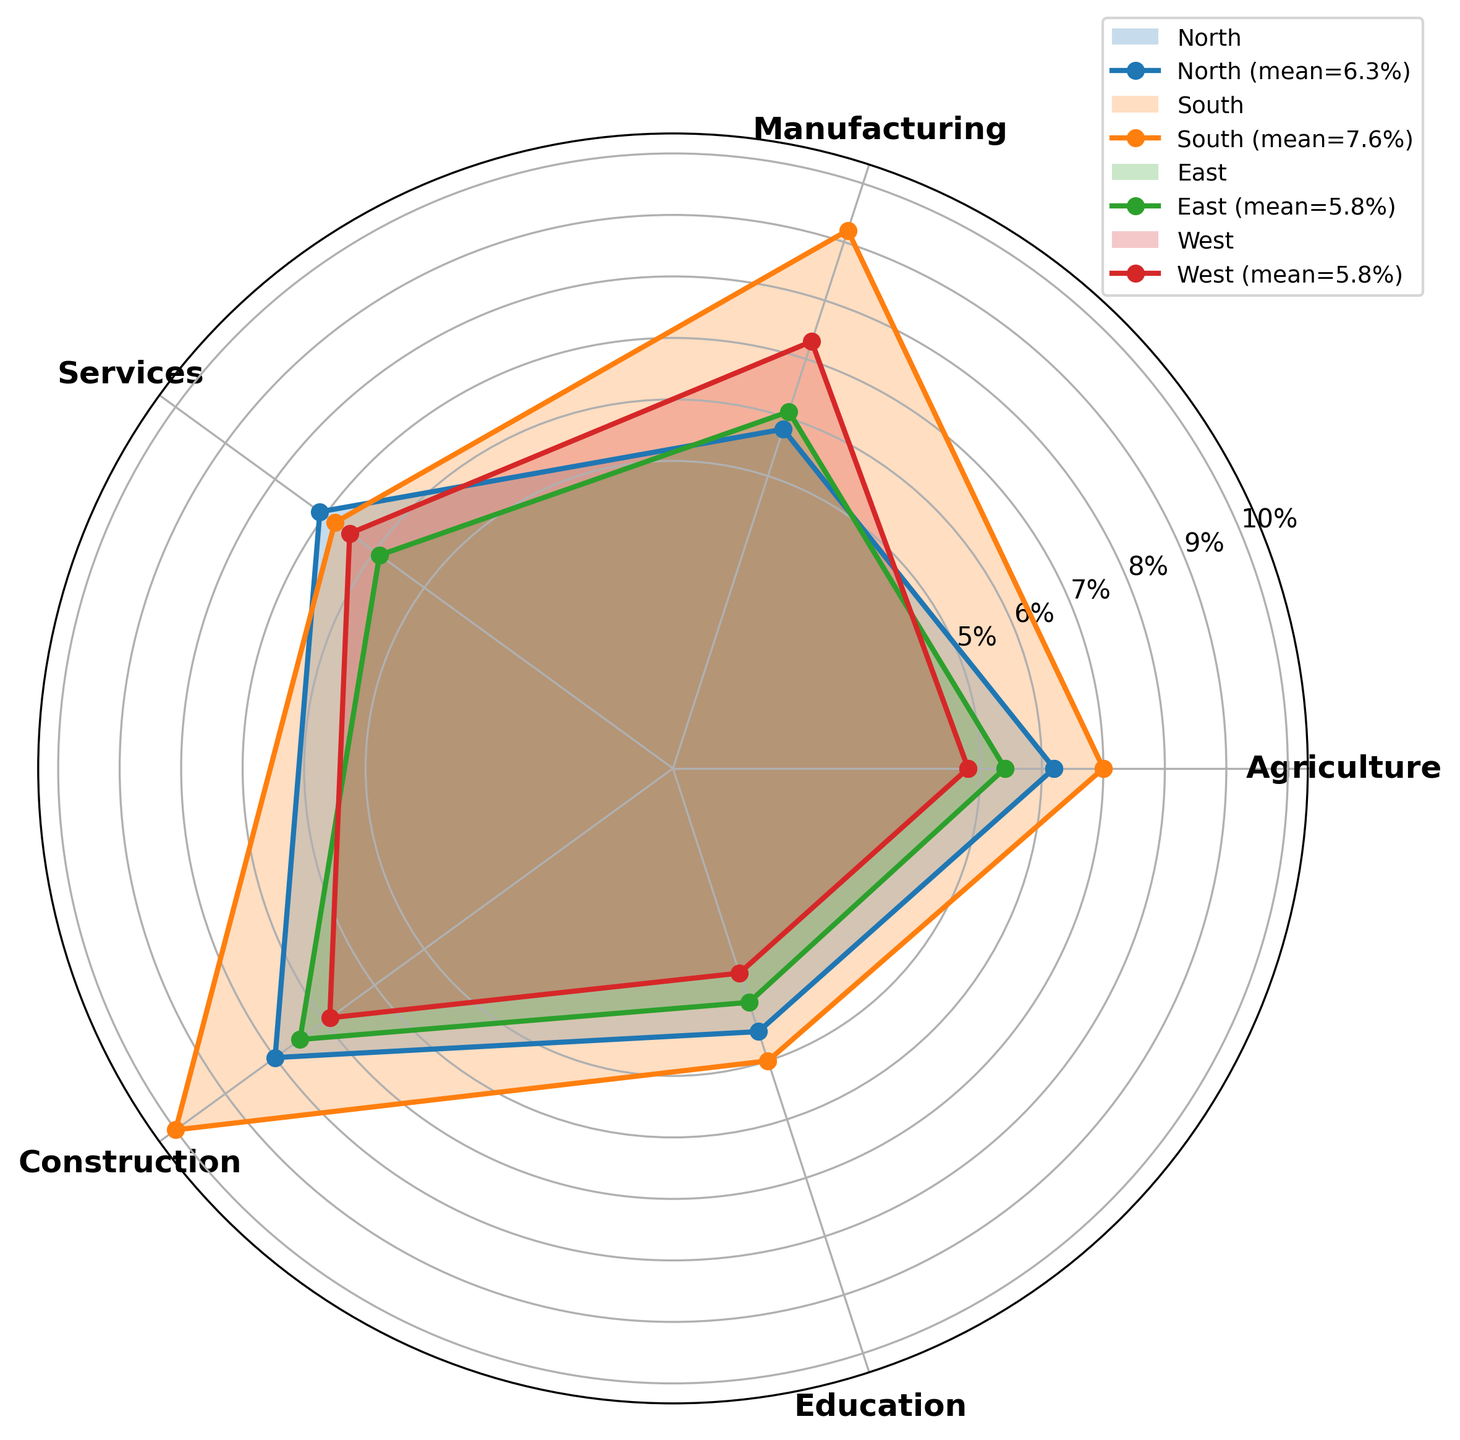What's the average unemployment rate in the North region? To find the average unemployment rate in the North region, sum the unemployment rates for each industry and then divide by the number of industries: (6.2 + 5.8 + 7.1 + 8.0 + 4.5) / 5 = 31.6 / 5 = 6.32.
Answer: 6.3 Which region has the highest unemployment rate in the Construction sector? Look at the Construction sector for each region on the radar chart and identify the highest value: North (8.0%), South (10.0%), East (7.5%), and West (6.9%). The South region has the highest rate at 10.0%.
Answer: South What's the difference in unemployment rates in the Education sector between the East and West regions? Locate the Education sector for East (4.0%) and West (3.5%) on the radar chart and find the difference: 4.0% - 3.5% = 0.5%.
Answer: 0.5% Which sector in the South region has the lowest unemployment rate? Identify the sector with the smallest value in the South region: Agriculture (7.0%), Manufacturing (9.2%), Services (6.8%), Construction (10.0%), Education (5.0%). The Education sector has the lowest rate at 5.0%.
Answer: Education How does the average unemployment rate in the East region compare to the average in the West region? Calculate the average for both regions: East ( (5.4+6.1+5.9+7.5+4.0) / 5 = 5.78%) and West ( (4.8+7.3+6.5+6.9+3.5) / 5 = 5.80%). Compare the values: since 5.78% < 5.80%, the East region's average is slightly lower.
Answer: East region is slightly lower What's the average unemployment rate in the Services sector across all regions? Sum the unemployment rates in the Services sector for each region and then divide by the number of regions: (7.1 + 6.8 + 5.9 + 6.5) / 4 = 26.3 / 4 = 6.575%.
Answer: 6.6% Between Agriculture and Manufacturing sectors in the North region, which has a higher unemployment rate? Compare the values for Agriculture (6.2%) and Manufacturing (5.8%) in the North region. Agriculture is higher at 6.2%.
Answer: Agriculture Which region has the most even unemployment rates across all its sectors? Check the radar chart for the region that forms the most balanced and least variable shape among sectors. The East region appears fairly even across sectors (5.4%, 6.1%, 5.9%, 7.5%, 4.0%).
Answer: East Is there any sector in the South region that has an unemployment rate higher than 9%? If so, which one? Identify sectors in the South region with rates higher than 9%: Agriculture (7.0%), Manufacturing (9.2%), Services (6.8%), Construction (10.0%), Education (5.0%). Both Construction (10.0%) and Manufacturing (9.2%) fit this criterion.
Answer: Manufacturing, Construction 